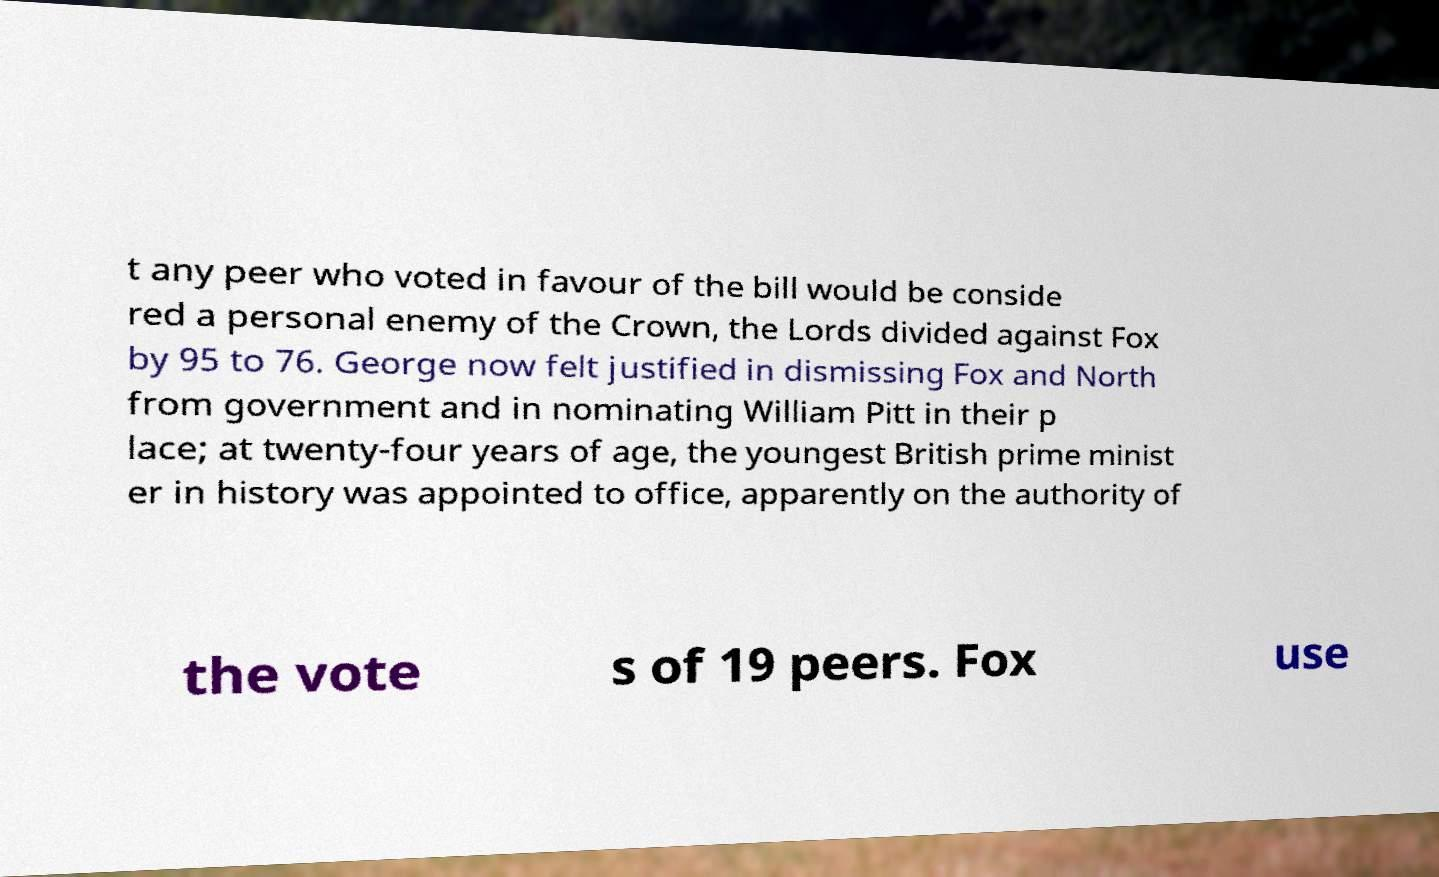Please identify and transcribe the text found in this image. t any peer who voted in favour of the bill would be conside red a personal enemy of the Crown, the Lords divided against Fox by 95 to 76. George now felt justified in dismissing Fox and North from government and in nominating William Pitt in their p lace; at twenty-four years of age, the youngest British prime minist er in history was appointed to office, apparently on the authority of the vote s of 19 peers. Fox use 